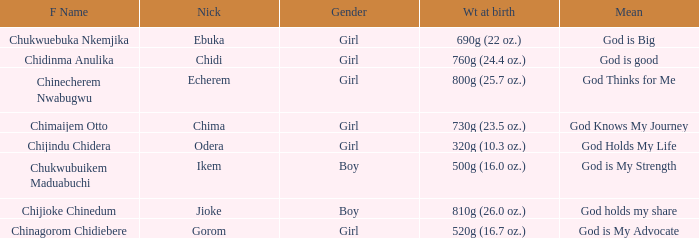What is the nickname of the boy who weighed 810g (26.0 oz.) at birth? Jioke. 